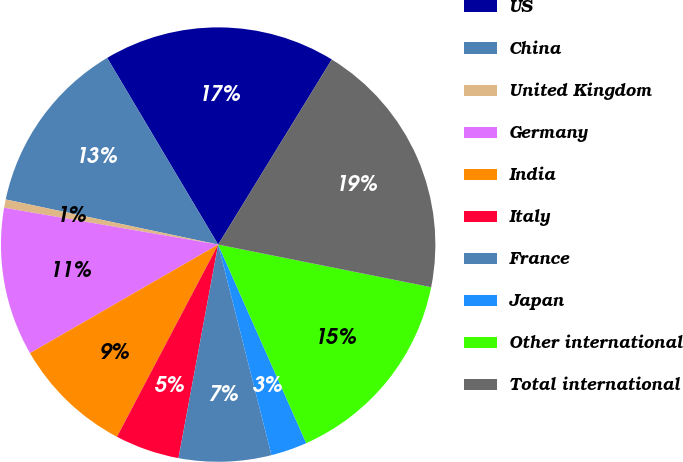Convert chart to OTSL. <chart><loc_0><loc_0><loc_500><loc_500><pie_chart><fcel>US<fcel>China<fcel>United Kingdom<fcel>Germany<fcel>India<fcel>Italy<fcel>France<fcel>Japan<fcel>Other international<fcel>Total international<nl><fcel>17.3%<fcel>13.13%<fcel>0.62%<fcel>11.04%<fcel>8.96%<fcel>4.79%<fcel>6.87%<fcel>2.7%<fcel>15.21%<fcel>19.38%<nl></chart> 